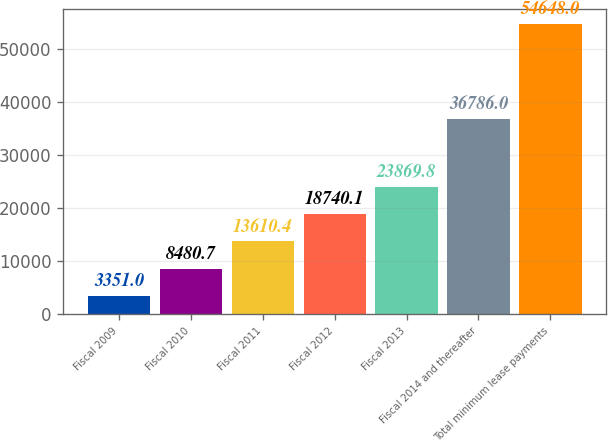<chart> <loc_0><loc_0><loc_500><loc_500><bar_chart><fcel>Fiscal 2009<fcel>Fiscal 2010<fcel>Fiscal 2011<fcel>Fiscal 2012<fcel>Fiscal 2013<fcel>Fiscal 2014 and thereafter<fcel>Total minimum lease payments<nl><fcel>3351<fcel>8480.7<fcel>13610.4<fcel>18740.1<fcel>23869.8<fcel>36786<fcel>54648<nl></chart> 